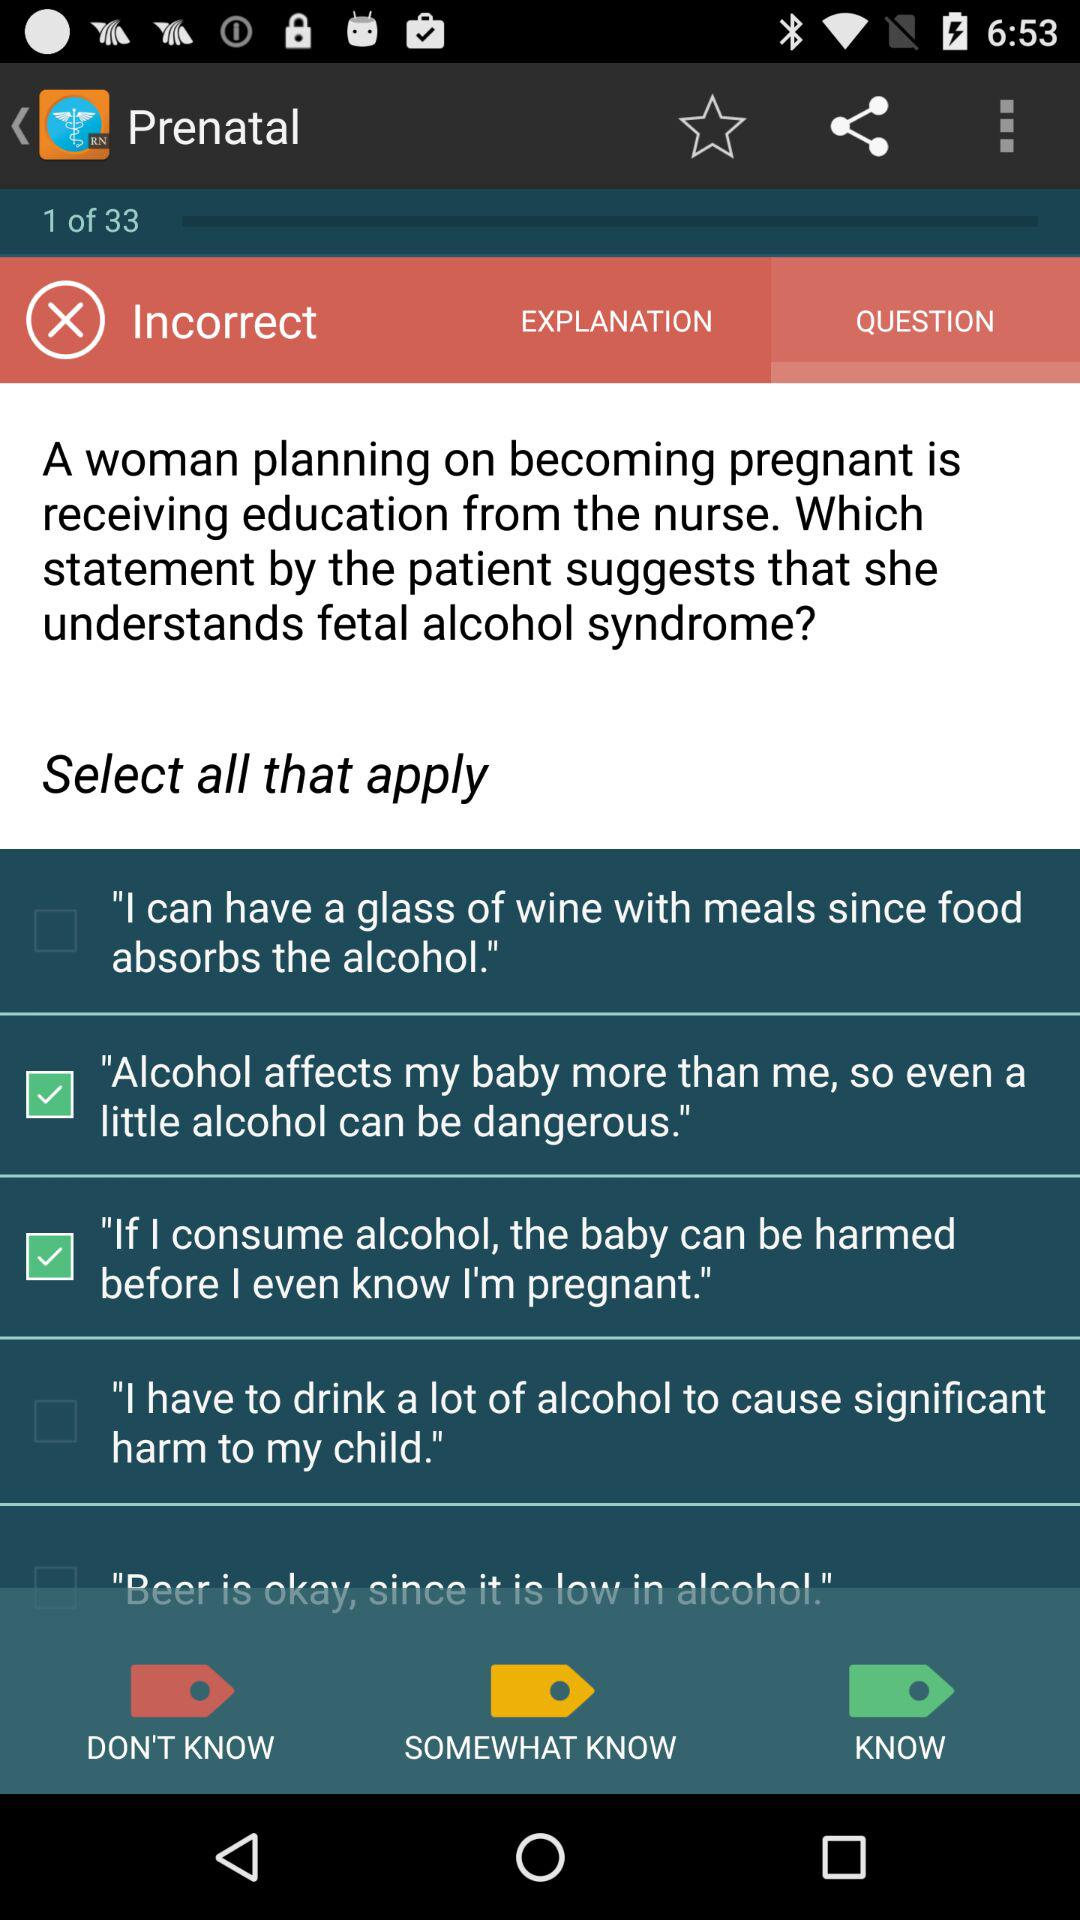I am at what question? You are on question 1. 